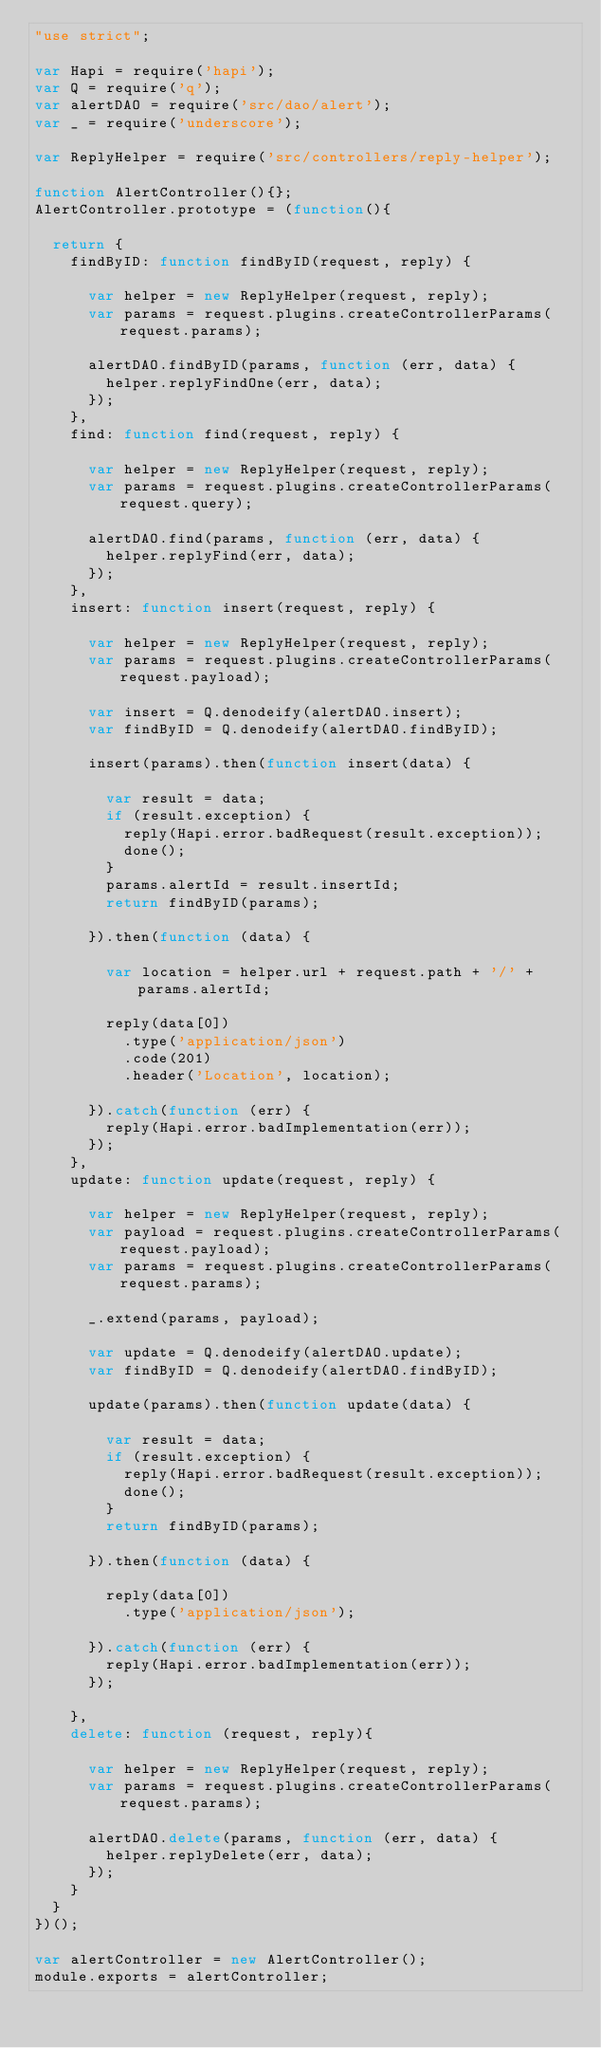<code> <loc_0><loc_0><loc_500><loc_500><_JavaScript_>"use strict";

var Hapi = require('hapi');
var Q = require('q');
var alertDAO = require('src/dao/alert');
var _ = require('underscore');

var ReplyHelper = require('src/controllers/reply-helper');

function AlertController(){};
AlertController.prototype = (function(){

	return {
		findByID: function findByID(request, reply) {

			var helper = new ReplyHelper(request, reply);
			var params = request.plugins.createControllerParams(request.params);

			alertDAO.findByID(params, function (err, data) {
				helper.replyFindOne(err, data);
			});
		},
		find: function find(request, reply) {

			var helper = new ReplyHelper(request, reply);
			var params = request.plugins.createControllerParams(request.query);

			alertDAO.find(params, function (err, data) {
				helper.replyFind(err, data);
			});
		},
		insert: function insert(request, reply) {

			var helper = new ReplyHelper(request, reply);
			var params = request.plugins.createControllerParams(request.payload);
			
			var insert = Q.denodeify(alertDAO.insert);
			var findByID = Q.denodeify(alertDAO.findByID);

			insert(params).then(function insert(data) {

				var result = data;
				if (result.exception) {
					reply(Hapi.error.badRequest(result.exception));
					done();
				} 
				params.alertId = result.insertId;
				return findByID(params);

			}).then(function (data) {

				var location = helper.url + request.path + '/' + params.alertId;

				reply(data[0])
					.type('application/json')
					.code(201)
					.header('Location', location);

			}).catch(function (err) {
				reply(Hapi.error.badImplementation(err));
			});
		},
		update: function update(request, reply) {

			var helper = new ReplyHelper(request, reply);
			var payload = request.plugins.createControllerParams(request.payload);
			var params = request.plugins.createControllerParams(request.params);

			_.extend(params, payload);
			
			var update = Q.denodeify(alertDAO.update);
			var findByID = Q.denodeify(alertDAO.findByID);

			update(params).then(function update(data) {

				var result = data;
				if (result.exception) {
					reply(Hapi.error.badRequest(result.exception));
					done();
				}
				return findByID(params);

			}).then(function (data) {

				reply(data[0])
					.type('application/json');

			}).catch(function (err) {
				reply(Hapi.error.badImplementation(err));
			});

		},
		delete: function (request, reply){

			var helper = new ReplyHelper(request, reply);
			var params = request.plugins.createControllerParams(request.params);

			alertDAO.delete(params, function (err, data) {
				helper.replyDelete(err, data);
			});
		}
	}
})();

var alertController = new AlertController();
module.exports = alertController;</code> 